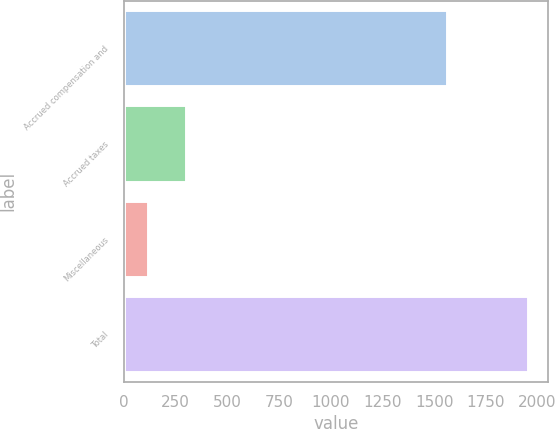<chart> <loc_0><loc_0><loc_500><loc_500><bar_chart><fcel>Accrued compensation and<fcel>Accrued taxes<fcel>Miscellaneous<fcel>Total<nl><fcel>1560.2<fcel>299.33<fcel>115.6<fcel>1952.9<nl></chart> 